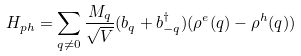Convert formula to latex. <formula><loc_0><loc_0><loc_500><loc_500>H _ { p h } = \sum _ { { q } \neq 0 } \frac { M _ { q } } { \sqrt { V } } ( b _ { q } + b ^ { \dagger } _ { - { q } } ) ( \rho ^ { e } ( { q } ) - \rho ^ { h } ( { q } ) )</formula> 